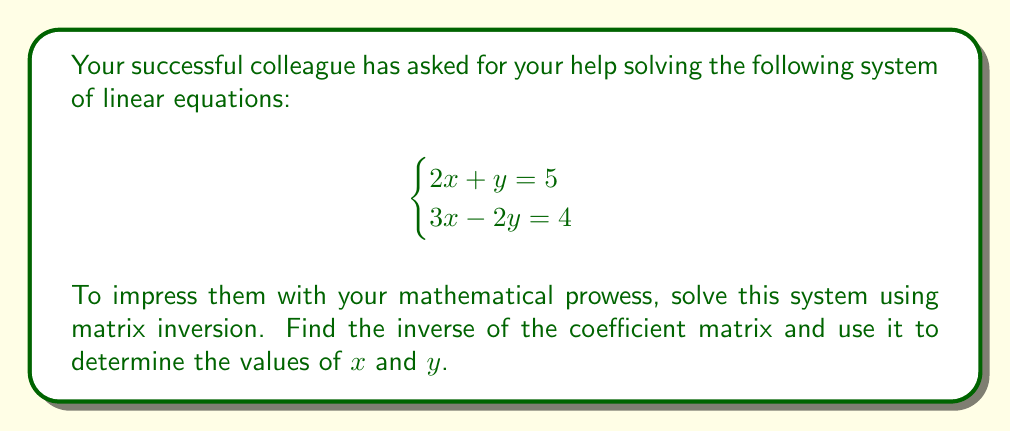Teach me how to tackle this problem. Let's solve this step-by-step:

1) First, we need to express the system as a matrix equation:

   $$\begin{pmatrix}
   2 & 1 \\
   3 & -2
   \end{pmatrix}
   \begin{pmatrix}
   x \\
   y
   \end{pmatrix} =
   \begin{pmatrix}
   5 \\
   4
   \end{pmatrix}$$

2) Let's call the coefficient matrix $A$. We need to find $A^{-1}$.

3) For a 2x2 matrix $\begin{pmatrix}
   a & b \\
   c & d
   \end{pmatrix}$, its inverse is:

   $$\frac{1}{ad-bc}\begin{pmatrix}
   d & -b \\
   -c & a
   \end{pmatrix}$$

4) In our case, $a=2$, $b=1$, $c=3$, and $d=-2$.

5) First, let's calculate the determinant: $ad-bc = (2)(-2) - (1)(3) = -4 - 3 = -7$

6) Now we can calculate $A^{-1}$:

   $$A^{-1} = \frac{1}{-7}\begin{pmatrix}
   -2 & -1 \\
   -3 & 2
   \end{pmatrix}$$

7) To solve the system, we multiply both sides by $A^{-1}$:

   $$\begin{pmatrix}
   x \\
   y
   \end{pmatrix} = \frac{1}{-7}\begin{pmatrix}
   -2 & -1 \\
   -3 & 2
   \end{pmatrix}
   \begin{pmatrix}
   5 \\
   4
   \end{pmatrix}$$

8) Performing the matrix multiplication:

   $$\begin{pmatrix}
   x \\
   y
   \end{pmatrix} = \frac{1}{-7}\begin{pmatrix}
   (-2)(5) + (-1)(4) \\
   (-3)(5) + (2)(4)
   \end{pmatrix} = \frac{1}{-7}\begin{pmatrix}
   -14 \\
   -7
   \end{pmatrix}$$

9) Simplifying:

   $$\begin{pmatrix}
   x \\
   y
   \end{pmatrix} = \begin{pmatrix}
   2 \\
   1
   \end{pmatrix}$$
Answer: The solution to the system of equations is $x = 2$ and $y = 1$. 